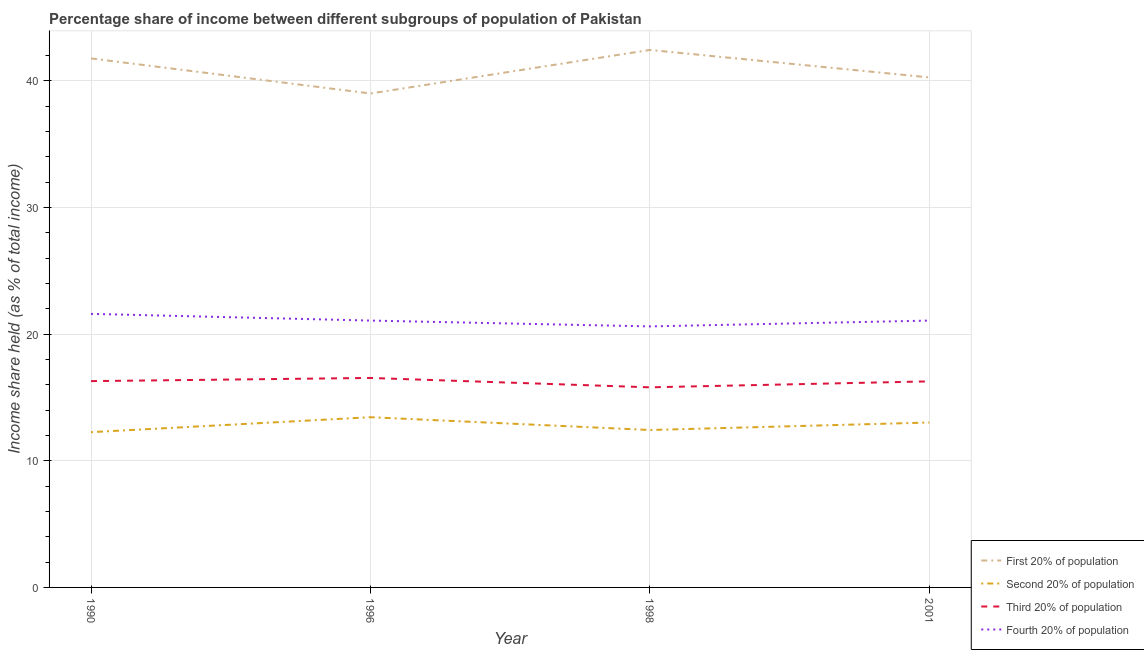How many different coloured lines are there?
Your response must be concise. 4. Does the line corresponding to share of the income held by third 20% of the population intersect with the line corresponding to share of the income held by first 20% of the population?
Keep it short and to the point. No. Is the number of lines equal to the number of legend labels?
Provide a short and direct response. Yes. What is the share of the income held by third 20% of the population in 1990?
Offer a very short reply. 16.29. Across all years, what is the maximum share of the income held by third 20% of the population?
Give a very brief answer. 16.54. What is the total share of the income held by first 20% of the population in the graph?
Your answer should be compact. 163.48. What is the difference between the share of the income held by third 20% of the population in 1998 and that in 2001?
Your answer should be compact. -0.47. What is the difference between the share of the income held by third 20% of the population in 2001 and the share of the income held by second 20% of the population in 1996?
Provide a succinct answer. 2.83. What is the average share of the income held by third 20% of the population per year?
Your response must be concise. 16.22. In the year 2001, what is the difference between the share of the income held by fourth 20% of the population and share of the income held by second 20% of the population?
Offer a very short reply. 8.05. In how many years, is the share of the income held by third 20% of the population greater than 2 %?
Offer a very short reply. 4. What is the ratio of the share of the income held by second 20% of the population in 1996 to that in 1998?
Your response must be concise. 1.08. Is the share of the income held by first 20% of the population in 1990 less than that in 1996?
Make the answer very short. No. What is the difference between the highest and the second highest share of the income held by second 20% of the population?
Your response must be concise. 0.42. What is the difference between the highest and the lowest share of the income held by fourth 20% of the population?
Ensure brevity in your answer.  0.99. Is the sum of the share of the income held by fourth 20% of the population in 1990 and 1996 greater than the maximum share of the income held by first 20% of the population across all years?
Provide a short and direct response. Yes. Is it the case that in every year, the sum of the share of the income held by second 20% of the population and share of the income held by first 20% of the population is greater than the sum of share of the income held by fourth 20% of the population and share of the income held by third 20% of the population?
Your response must be concise. Yes. Is the share of the income held by first 20% of the population strictly greater than the share of the income held by third 20% of the population over the years?
Offer a very short reply. Yes. Is the share of the income held by second 20% of the population strictly less than the share of the income held by third 20% of the population over the years?
Make the answer very short. Yes. How many years are there in the graph?
Keep it short and to the point. 4. What is the difference between two consecutive major ticks on the Y-axis?
Provide a short and direct response. 10. Does the graph contain any zero values?
Provide a succinct answer. No. Does the graph contain grids?
Offer a terse response. Yes. How many legend labels are there?
Your answer should be compact. 4. What is the title of the graph?
Offer a terse response. Percentage share of income between different subgroups of population of Pakistan. Does "Services" appear as one of the legend labels in the graph?
Make the answer very short. No. What is the label or title of the Y-axis?
Your answer should be very brief. Income share held (as % of total income). What is the Income share held (as % of total income) of First 20% of population in 1990?
Give a very brief answer. 41.77. What is the Income share held (as % of total income) in Second 20% of population in 1990?
Make the answer very short. 12.26. What is the Income share held (as % of total income) in Third 20% of population in 1990?
Give a very brief answer. 16.29. What is the Income share held (as % of total income) of Fourth 20% of population in 1990?
Make the answer very short. 21.6. What is the Income share held (as % of total income) of Second 20% of population in 1996?
Make the answer very short. 13.44. What is the Income share held (as % of total income) in Third 20% of population in 1996?
Ensure brevity in your answer.  16.54. What is the Income share held (as % of total income) in Fourth 20% of population in 1996?
Keep it short and to the point. 21.07. What is the Income share held (as % of total income) in First 20% of population in 1998?
Offer a very short reply. 42.44. What is the Income share held (as % of total income) in Second 20% of population in 1998?
Give a very brief answer. 12.43. What is the Income share held (as % of total income) of Third 20% of population in 1998?
Give a very brief answer. 15.8. What is the Income share held (as % of total income) in Fourth 20% of population in 1998?
Make the answer very short. 20.61. What is the Income share held (as % of total income) of First 20% of population in 2001?
Make the answer very short. 40.27. What is the Income share held (as % of total income) in Second 20% of population in 2001?
Give a very brief answer. 13.02. What is the Income share held (as % of total income) in Third 20% of population in 2001?
Offer a terse response. 16.27. What is the Income share held (as % of total income) in Fourth 20% of population in 2001?
Your answer should be very brief. 21.07. Across all years, what is the maximum Income share held (as % of total income) of First 20% of population?
Ensure brevity in your answer.  42.44. Across all years, what is the maximum Income share held (as % of total income) in Second 20% of population?
Ensure brevity in your answer.  13.44. Across all years, what is the maximum Income share held (as % of total income) in Third 20% of population?
Provide a succinct answer. 16.54. Across all years, what is the maximum Income share held (as % of total income) of Fourth 20% of population?
Provide a short and direct response. 21.6. Across all years, what is the minimum Income share held (as % of total income) of Second 20% of population?
Your answer should be very brief. 12.26. Across all years, what is the minimum Income share held (as % of total income) in Third 20% of population?
Keep it short and to the point. 15.8. Across all years, what is the minimum Income share held (as % of total income) in Fourth 20% of population?
Make the answer very short. 20.61. What is the total Income share held (as % of total income) in First 20% of population in the graph?
Keep it short and to the point. 163.48. What is the total Income share held (as % of total income) of Second 20% of population in the graph?
Your answer should be very brief. 51.15. What is the total Income share held (as % of total income) in Third 20% of population in the graph?
Make the answer very short. 64.9. What is the total Income share held (as % of total income) in Fourth 20% of population in the graph?
Make the answer very short. 84.35. What is the difference between the Income share held (as % of total income) in First 20% of population in 1990 and that in 1996?
Make the answer very short. 2.77. What is the difference between the Income share held (as % of total income) in Second 20% of population in 1990 and that in 1996?
Provide a short and direct response. -1.18. What is the difference between the Income share held (as % of total income) of Fourth 20% of population in 1990 and that in 1996?
Ensure brevity in your answer.  0.53. What is the difference between the Income share held (as % of total income) in First 20% of population in 1990 and that in 1998?
Your answer should be compact. -0.67. What is the difference between the Income share held (as % of total income) in Second 20% of population in 1990 and that in 1998?
Offer a very short reply. -0.17. What is the difference between the Income share held (as % of total income) in Third 20% of population in 1990 and that in 1998?
Offer a very short reply. 0.49. What is the difference between the Income share held (as % of total income) of First 20% of population in 1990 and that in 2001?
Your response must be concise. 1.5. What is the difference between the Income share held (as % of total income) in Second 20% of population in 1990 and that in 2001?
Offer a very short reply. -0.76. What is the difference between the Income share held (as % of total income) in Third 20% of population in 1990 and that in 2001?
Your answer should be very brief. 0.02. What is the difference between the Income share held (as % of total income) in Fourth 20% of population in 1990 and that in 2001?
Keep it short and to the point. 0.53. What is the difference between the Income share held (as % of total income) of First 20% of population in 1996 and that in 1998?
Offer a terse response. -3.44. What is the difference between the Income share held (as % of total income) of Second 20% of population in 1996 and that in 1998?
Your answer should be compact. 1.01. What is the difference between the Income share held (as % of total income) in Third 20% of population in 1996 and that in 1998?
Your answer should be compact. 0.74. What is the difference between the Income share held (as % of total income) of Fourth 20% of population in 1996 and that in 1998?
Offer a very short reply. 0.46. What is the difference between the Income share held (as % of total income) of First 20% of population in 1996 and that in 2001?
Keep it short and to the point. -1.27. What is the difference between the Income share held (as % of total income) in Second 20% of population in 1996 and that in 2001?
Ensure brevity in your answer.  0.42. What is the difference between the Income share held (as % of total income) in Third 20% of population in 1996 and that in 2001?
Ensure brevity in your answer.  0.27. What is the difference between the Income share held (as % of total income) in Fourth 20% of population in 1996 and that in 2001?
Provide a succinct answer. 0. What is the difference between the Income share held (as % of total income) of First 20% of population in 1998 and that in 2001?
Keep it short and to the point. 2.17. What is the difference between the Income share held (as % of total income) of Second 20% of population in 1998 and that in 2001?
Your response must be concise. -0.59. What is the difference between the Income share held (as % of total income) of Third 20% of population in 1998 and that in 2001?
Your answer should be very brief. -0.47. What is the difference between the Income share held (as % of total income) of Fourth 20% of population in 1998 and that in 2001?
Your answer should be compact. -0.46. What is the difference between the Income share held (as % of total income) in First 20% of population in 1990 and the Income share held (as % of total income) in Second 20% of population in 1996?
Make the answer very short. 28.33. What is the difference between the Income share held (as % of total income) in First 20% of population in 1990 and the Income share held (as % of total income) in Third 20% of population in 1996?
Your response must be concise. 25.23. What is the difference between the Income share held (as % of total income) of First 20% of population in 1990 and the Income share held (as % of total income) of Fourth 20% of population in 1996?
Make the answer very short. 20.7. What is the difference between the Income share held (as % of total income) in Second 20% of population in 1990 and the Income share held (as % of total income) in Third 20% of population in 1996?
Offer a terse response. -4.28. What is the difference between the Income share held (as % of total income) in Second 20% of population in 1990 and the Income share held (as % of total income) in Fourth 20% of population in 1996?
Make the answer very short. -8.81. What is the difference between the Income share held (as % of total income) in Third 20% of population in 1990 and the Income share held (as % of total income) in Fourth 20% of population in 1996?
Your answer should be compact. -4.78. What is the difference between the Income share held (as % of total income) in First 20% of population in 1990 and the Income share held (as % of total income) in Second 20% of population in 1998?
Give a very brief answer. 29.34. What is the difference between the Income share held (as % of total income) in First 20% of population in 1990 and the Income share held (as % of total income) in Third 20% of population in 1998?
Your answer should be very brief. 25.97. What is the difference between the Income share held (as % of total income) of First 20% of population in 1990 and the Income share held (as % of total income) of Fourth 20% of population in 1998?
Provide a short and direct response. 21.16. What is the difference between the Income share held (as % of total income) in Second 20% of population in 1990 and the Income share held (as % of total income) in Third 20% of population in 1998?
Make the answer very short. -3.54. What is the difference between the Income share held (as % of total income) of Second 20% of population in 1990 and the Income share held (as % of total income) of Fourth 20% of population in 1998?
Offer a very short reply. -8.35. What is the difference between the Income share held (as % of total income) in Third 20% of population in 1990 and the Income share held (as % of total income) in Fourth 20% of population in 1998?
Your answer should be compact. -4.32. What is the difference between the Income share held (as % of total income) of First 20% of population in 1990 and the Income share held (as % of total income) of Second 20% of population in 2001?
Give a very brief answer. 28.75. What is the difference between the Income share held (as % of total income) in First 20% of population in 1990 and the Income share held (as % of total income) in Fourth 20% of population in 2001?
Ensure brevity in your answer.  20.7. What is the difference between the Income share held (as % of total income) in Second 20% of population in 1990 and the Income share held (as % of total income) in Third 20% of population in 2001?
Your answer should be very brief. -4.01. What is the difference between the Income share held (as % of total income) of Second 20% of population in 1990 and the Income share held (as % of total income) of Fourth 20% of population in 2001?
Provide a short and direct response. -8.81. What is the difference between the Income share held (as % of total income) of Third 20% of population in 1990 and the Income share held (as % of total income) of Fourth 20% of population in 2001?
Keep it short and to the point. -4.78. What is the difference between the Income share held (as % of total income) in First 20% of population in 1996 and the Income share held (as % of total income) in Second 20% of population in 1998?
Your response must be concise. 26.57. What is the difference between the Income share held (as % of total income) of First 20% of population in 1996 and the Income share held (as % of total income) of Third 20% of population in 1998?
Offer a very short reply. 23.2. What is the difference between the Income share held (as % of total income) in First 20% of population in 1996 and the Income share held (as % of total income) in Fourth 20% of population in 1998?
Your answer should be very brief. 18.39. What is the difference between the Income share held (as % of total income) of Second 20% of population in 1996 and the Income share held (as % of total income) of Third 20% of population in 1998?
Keep it short and to the point. -2.36. What is the difference between the Income share held (as % of total income) of Second 20% of population in 1996 and the Income share held (as % of total income) of Fourth 20% of population in 1998?
Make the answer very short. -7.17. What is the difference between the Income share held (as % of total income) in Third 20% of population in 1996 and the Income share held (as % of total income) in Fourth 20% of population in 1998?
Give a very brief answer. -4.07. What is the difference between the Income share held (as % of total income) in First 20% of population in 1996 and the Income share held (as % of total income) in Second 20% of population in 2001?
Make the answer very short. 25.98. What is the difference between the Income share held (as % of total income) of First 20% of population in 1996 and the Income share held (as % of total income) of Third 20% of population in 2001?
Your response must be concise. 22.73. What is the difference between the Income share held (as % of total income) of First 20% of population in 1996 and the Income share held (as % of total income) of Fourth 20% of population in 2001?
Your answer should be very brief. 17.93. What is the difference between the Income share held (as % of total income) of Second 20% of population in 1996 and the Income share held (as % of total income) of Third 20% of population in 2001?
Your answer should be compact. -2.83. What is the difference between the Income share held (as % of total income) of Second 20% of population in 1996 and the Income share held (as % of total income) of Fourth 20% of population in 2001?
Provide a succinct answer. -7.63. What is the difference between the Income share held (as % of total income) in Third 20% of population in 1996 and the Income share held (as % of total income) in Fourth 20% of population in 2001?
Provide a succinct answer. -4.53. What is the difference between the Income share held (as % of total income) in First 20% of population in 1998 and the Income share held (as % of total income) in Second 20% of population in 2001?
Your answer should be compact. 29.42. What is the difference between the Income share held (as % of total income) in First 20% of population in 1998 and the Income share held (as % of total income) in Third 20% of population in 2001?
Provide a short and direct response. 26.17. What is the difference between the Income share held (as % of total income) of First 20% of population in 1998 and the Income share held (as % of total income) of Fourth 20% of population in 2001?
Offer a terse response. 21.37. What is the difference between the Income share held (as % of total income) in Second 20% of population in 1998 and the Income share held (as % of total income) in Third 20% of population in 2001?
Offer a very short reply. -3.84. What is the difference between the Income share held (as % of total income) of Second 20% of population in 1998 and the Income share held (as % of total income) of Fourth 20% of population in 2001?
Your response must be concise. -8.64. What is the difference between the Income share held (as % of total income) of Third 20% of population in 1998 and the Income share held (as % of total income) of Fourth 20% of population in 2001?
Make the answer very short. -5.27. What is the average Income share held (as % of total income) in First 20% of population per year?
Offer a terse response. 40.87. What is the average Income share held (as % of total income) of Second 20% of population per year?
Provide a short and direct response. 12.79. What is the average Income share held (as % of total income) of Third 20% of population per year?
Your response must be concise. 16.23. What is the average Income share held (as % of total income) in Fourth 20% of population per year?
Provide a short and direct response. 21.09. In the year 1990, what is the difference between the Income share held (as % of total income) in First 20% of population and Income share held (as % of total income) in Second 20% of population?
Make the answer very short. 29.51. In the year 1990, what is the difference between the Income share held (as % of total income) in First 20% of population and Income share held (as % of total income) in Third 20% of population?
Offer a very short reply. 25.48. In the year 1990, what is the difference between the Income share held (as % of total income) of First 20% of population and Income share held (as % of total income) of Fourth 20% of population?
Your response must be concise. 20.17. In the year 1990, what is the difference between the Income share held (as % of total income) of Second 20% of population and Income share held (as % of total income) of Third 20% of population?
Your answer should be compact. -4.03. In the year 1990, what is the difference between the Income share held (as % of total income) in Second 20% of population and Income share held (as % of total income) in Fourth 20% of population?
Keep it short and to the point. -9.34. In the year 1990, what is the difference between the Income share held (as % of total income) of Third 20% of population and Income share held (as % of total income) of Fourth 20% of population?
Ensure brevity in your answer.  -5.31. In the year 1996, what is the difference between the Income share held (as % of total income) in First 20% of population and Income share held (as % of total income) in Second 20% of population?
Give a very brief answer. 25.56. In the year 1996, what is the difference between the Income share held (as % of total income) of First 20% of population and Income share held (as % of total income) of Third 20% of population?
Your response must be concise. 22.46. In the year 1996, what is the difference between the Income share held (as % of total income) in First 20% of population and Income share held (as % of total income) in Fourth 20% of population?
Your answer should be very brief. 17.93. In the year 1996, what is the difference between the Income share held (as % of total income) of Second 20% of population and Income share held (as % of total income) of Third 20% of population?
Your answer should be very brief. -3.1. In the year 1996, what is the difference between the Income share held (as % of total income) of Second 20% of population and Income share held (as % of total income) of Fourth 20% of population?
Make the answer very short. -7.63. In the year 1996, what is the difference between the Income share held (as % of total income) of Third 20% of population and Income share held (as % of total income) of Fourth 20% of population?
Offer a very short reply. -4.53. In the year 1998, what is the difference between the Income share held (as % of total income) of First 20% of population and Income share held (as % of total income) of Second 20% of population?
Offer a very short reply. 30.01. In the year 1998, what is the difference between the Income share held (as % of total income) of First 20% of population and Income share held (as % of total income) of Third 20% of population?
Provide a succinct answer. 26.64. In the year 1998, what is the difference between the Income share held (as % of total income) of First 20% of population and Income share held (as % of total income) of Fourth 20% of population?
Your answer should be very brief. 21.83. In the year 1998, what is the difference between the Income share held (as % of total income) of Second 20% of population and Income share held (as % of total income) of Third 20% of population?
Provide a short and direct response. -3.37. In the year 1998, what is the difference between the Income share held (as % of total income) in Second 20% of population and Income share held (as % of total income) in Fourth 20% of population?
Keep it short and to the point. -8.18. In the year 1998, what is the difference between the Income share held (as % of total income) of Third 20% of population and Income share held (as % of total income) of Fourth 20% of population?
Give a very brief answer. -4.81. In the year 2001, what is the difference between the Income share held (as % of total income) of First 20% of population and Income share held (as % of total income) of Second 20% of population?
Provide a succinct answer. 27.25. In the year 2001, what is the difference between the Income share held (as % of total income) of First 20% of population and Income share held (as % of total income) of Third 20% of population?
Your answer should be compact. 24. In the year 2001, what is the difference between the Income share held (as % of total income) in First 20% of population and Income share held (as % of total income) in Fourth 20% of population?
Give a very brief answer. 19.2. In the year 2001, what is the difference between the Income share held (as % of total income) in Second 20% of population and Income share held (as % of total income) in Third 20% of population?
Your answer should be very brief. -3.25. In the year 2001, what is the difference between the Income share held (as % of total income) in Second 20% of population and Income share held (as % of total income) in Fourth 20% of population?
Give a very brief answer. -8.05. In the year 2001, what is the difference between the Income share held (as % of total income) in Third 20% of population and Income share held (as % of total income) in Fourth 20% of population?
Provide a short and direct response. -4.8. What is the ratio of the Income share held (as % of total income) of First 20% of population in 1990 to that in 1996?
Make the answer very short. 1.07. What is the ratio of the Income share held (as % of total income) in Second 20% of population in 1990 to that in 1996?
Ensure brevity in your answer.  0.91. What is the ratio of the Income share held (as % of total income) of Third 20% of population in 1990 to that in 1996?
Provide a short and direct response. 0.98. What is the ratio of the Income share held (as % of total income) in Fourth 20% of population in 1990 to that in 1996?
Make the answer very short. 1.03. What is the ratio of the Income share held (as % of total income) in First 20% of population in 1990 to that in 1998?
Ensure brevity in your answer.  0.98. What is the ratio of the Income share held (as % of total income) of Second 20% of population in 1990 to that in 1998?
Your answer should be very brief. 0.99. What is the ratio of the Income share held (as % of total income) of Third 20% of population in 1990 to that in 1998?
Your answer should be compact. 1.03. What is the ratio of the Income share held (as % of total income) of Fourth 20% of population in 1990 to that in 1998?
Offer a very short reply. 1.05. What is the ratio of the Income share held (as % of total income) in First 20% of population in 1990 to that in 2001?
Give a very brief answer. 1.04. What is the ratio of the Income share held (as % of total income) in Second 20% of population in 1990 to that in 2001?
Keep it short and to the point. 0.94. What is the ratio of the Income share held (as % of total income) in Fourth 20% of population in 1990 to that in 2001?
Make the answer very short. 1.03. What is the ratio of the Income share held (as % of total income) of First 20% of population in 1996 to that in 1998?
Your answer should be compact. 0.92. What is the ratio of the Income share held (as % of total income) of Second 20% of population in 1996 to that in 1998?
Keep it short and to the point. 1.08. What is the ratio of the Income share held (as % of total income) of Third 20% of population in 1996 to that in 1998?
Ensure brevity in your answer.  1.05. What is the ratio of the Income share held (as % of total income) of Fourth 20% of population in 1996 to that in 1998?
Your answer should be compact. 1.02. What is the ratio of the Income share held (as % of total income) of First 20% of population in 1996 to that in 2001?
Your answer should be compact. 0.97. What is the ratio of the Income share held (as % of total income) in Second 20% of population in 1996 to that in 2001?
Give a very brief answer. 1.03. What is the ratio of the Income share held (as % of total income) of Third 20% of population in 1996 to that in 2001?
Keep it short and to the point. 1.02. What is the ratio of the Income share held (as % of total income) in First 20% of population in 1998 to that in 2001?
Offer a terse response. 1.05. What is the ratio of the Income share held (as % of total income) in Second 20% of population in 1998 to that in 2001?
Ensure brevity in your answer.  0.95. What is the ratio of the Income share held (as % of total income) of Third 20% of population in 1998 to that in 2001?
Offer a very short reply. 0.97. What is the ratio of the Income share held (as % of total income) in Fourth 20% of population in 1998 to that in 2001?
Offer a very short reply. 0.98. What is the difference between the highest and the second highest Income share held (as % of total income) of First 20% of population?
Offer a terse response. 0.67. What is the difference between the highest and the second highest Income share held (as % of total income) of Second 20% of population?
Provide a succinct answer. 0.42. What is the difference between the highest and the second highest Income share held (as % of total income) of Third 20% of population?
Your response must be concise. 0.25. What is the difference between the highest and the second highest Income share held (as % of total income) of Fourth 20% of population?
Keep it short and to the point. 0.53. What is the difference between the highest and the lowest Income share held (as % of total income) of First 20% of population?
Keep it short and to the point. 3.44. What is the difference between the highest and the lowest Income share held (as % of total income) in Second 20% of population?
Provide a succinct answer. 1.18. What is the difference between the highest and the lowest Income share held (as % of total income) in Third 20% of population?
Provide a short and direct response. 0.74. 